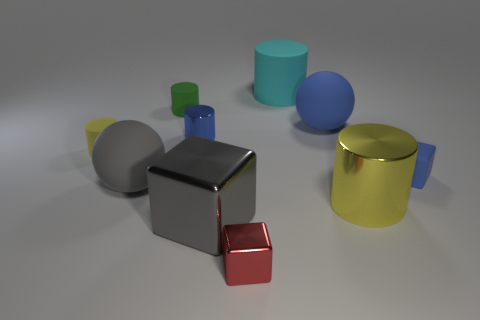Are there any other things that have the same material as the big cyan cylinder?
Your answer should be compact. Yes. How many rubber things are yellow things or small blue cubes?
Provide a succinct answer. 2. Do the tiny metal block and the small shiny cylinder have the same color?
Provide a short and direct response. No. Is there anything else that has the same color as the large matte cylinder?
Your response must be concise. No. There is a small blue thing that is to the right of the large cyan rubber thing; is its shape the same as the large object behind the green cylinder?
Offer a terse response. No. What number of things are big cubes or large rubber objects in front of the cyan object?
Your answer should be compact. 3. What number of other objects are the same size as the yellow rubber cylinder?
Provide a succinct answer. 4. Does the sphere that is to the left of the blue shiny cylinder have the same material as the yellow object to the right of the gray metallic thing?
Keep it short and to the point. No. There is a green matte thing; how many small blue rubber blocks are in front of it?
Your answer should be compact. 1. What number of brown objects are large cubes or tiny metal cubes?
Give a very brief answer. 0. 